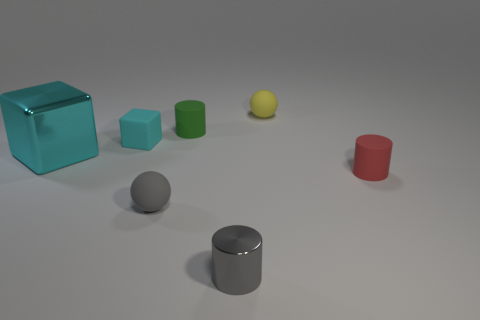Add 2 small yellow matte balls. How many objects exist? 9 Subtract all balls. How many objects are left? 5 Add 1 small cyan things. How many small cyan things are left? 2 Add 2 large purple matte blocks. How many large purple matte blocks exist? 2 Subtract 1 gray cylinders. How many objects are left? 6 Subtract all small red things. Subtract all small gray spheres. How many objects are left? 5 